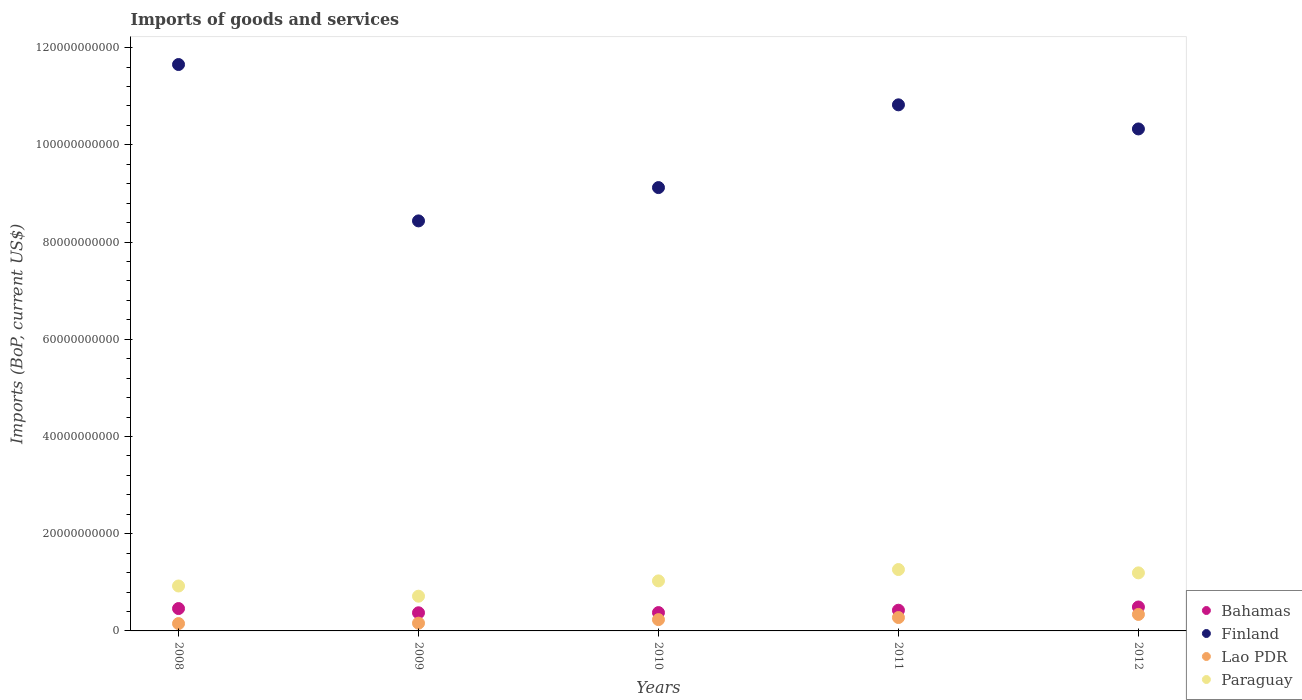How many different coloured dotlines are there?
Provide a short and direct response. 4. Is the number of dotlines equal to the number of legend labels?
Offer a very short reply. Yes. What is the amount spent on imports in Finland in 2011?
Your response must be concise. 1.08e+11. Across all years, what is the maximum amount spent on imports in Paraguay?
Your response must be concise. 1.26e+1. Across all years, what is the minimum amount spent on imports in Paraguay?
Your response must be concise. 7.14e+09. In which year was the amount spent on imports in Paraguay maximum?
Provide a short and direct response. 2011. In which year was the amount spent on imports in Bahamas minimum?
Ensure brevity in your answer.  2009. What is the total amount spent on imports in Bahamas in the graph?
Your answer should be compact. 2.13e+1. What is the difference between the amount spent on imports in Lao PDR in 2010 and that in 2012?
Your response must be concise. -1.07e+09. What is the difference between the amount spent on imports in Finland in 2010 and the amount spent on imports in Bahamas in 2012?
Your answer should be compact. 8.63e+1. What is the average amount spent on imports in Finland per year?
Keep it short and to the point. 1.01e+11. In the year 2011, what is the difference between the amount spent on imports in Bahamas and amount spent on imports in Finland?
Ensure brevity in your answer.  -1.04e+11. In how many years, is the amount spent on imports in Paraguay greater than 12000000000 US$?
Make the answer very short. 1. What is the ratio of the amount spent on imports in Lao PDR in 2008 to that in 2010?
Your answer should be compact. 0.65. Is the difference between the amount spent on imports in Bahamas in 2010 and 2012 greater than the difference between the amount spent on imports in Finland in 2010 and 2012?
Ensure brevity in your answer.  Yes. What is the difference between the highest and the second highest amount spent on imports in Bahamas?
Offer a terse response. 3.21e+08. What is the difference between the highest and the lowest amount spent on imports in Lao PDR?
Your answer should be very brief. 1.88e+09. Is the sum of the amount spent on imports in Paraguay in 2009 and 2011 greater than the maximum amount spent on imports in Bahamas across all years?
Offer a very short reply. Yes. Is it the case that in every year, the sum of the amount spent on imports in Finland and amount spent on imports in Lao PDR  is greater than the sum of amount spent on imports in Bahamas and amount spent on imports in Paraguay?
Your answer should be very brief. No. Does the amount spent on imports in Paraguay monotonically increase over the years?
Your answer should be compact. No. Is the amount spent on imports in Bahamas strictly greater than the amount spent on imports in Paraguay over the years?
Provide a short and direct response. No. What is the difference between two consecutive major ticks on the Y-axis?
Your answer should be very brief. 2.00e+1. Does the graph contain grids?
Your response must be concise. No. Where does the legend appear in the graph?
Make the answer very short. Bottom right. What is the title of the graph?
Keep it short and to the point. Imports of goods and services. Does "European Union" appear as one of the legend labels in the graph?
Provide a succinct answer. No. What is the label or title of the X-axis?
Provide a succinct answer. Years. What is the label or title of the Y-axis?
Keep it short and to the point. Imports (BoP, current US$). What is the Imports (BoP, current US$) of Bahamas in 2008?
Provide a succinct answer. 4.60e+09. What is the Imports (BoP, current US$) in Finland in 2008?
Your answer should be compact. 1.17e+11. What is the Imports (BoP, current US$) of Lao PDR in 2008?
Your answer should be compact. 1.51e+09. What is the Imports (BoP, current US$) of Paraguay in 2008?
Offer a very short reply. 9.24e+09. What is the Imports (BoP, current US$) of Bahamas in 2009?
Ensure brevity in your answer.  3.73e+09. What is the Imports (BoP, current US$) in Finland in 2009?
Keep it short and to the point. 8.43e+1. What is the Imports (BoP, current US$) in Lao PDR in 2009?
Provide a short and direct response. 1.60e+09. What is the Imports (BoP, current US$) of Paraguay in 2009?
Ensure brevity in your answer.  7.14e+09. What is the Imports (BoP, current US$) in Bahamas in 2010?
Your answer should be compact. 3.77e+09. What is the Imports (BoP, current US$) of Finland in 2010?
Give a very brief answer. 9.12e+1. What is the Imports (BoP, current US$) of Lao PDR in 2010?
Offer a very short reply. 2.32e+09. What is the Imports (BoP, current US$) in Paraguay in 2010?
Keep it short and to the point. 1.03e+1. What is the Imports (BoP, current US$) of Bahamas in 2011?
Your response must be concise. 4.26e+09. What is the Imports (BoP, current US$) in Finland in 2011?
Offer a terse response. 1.08e+11. What is the Imports (BoP, current US$) in Lao PDR in 2011?
Keep it short and to the point. 2.75e+09. What is the Imports (BoP, current US$) in Paraguay in 2011?
Your answer should be compact. 1.26e+1. What is the Imports (BoP, current US$) of Bahamas in 2012?
Provide a short and direct response. 4.92e+09. What is the Imports (BoP, current US$) in Finland in 2012?
Provide a succinct answer. 1.03e+11. What is the Imports (BoP, current US$) in Lao PDR in 2012?
Offer a very short reply. 3.39e+09. What is the Imports (BoP, current US$) in Paraguay in 2012?
Ensure brevity in your answer.  1.19e+1. Across all years, what is the maximum Imports (BoP, current US$) in Bahamas?
Provide a succinct answer. 4.92e+09. Across all years, what is the maximum Imports (BoP, current US$) of Finland?
Give a very brief answer. 1.17e+11. Across all years, what is the maximum Imports (BoP, current US$) of Lao PDR?
Give a very brief answer. 3.39e+09. Across all years, what is the maximum Imports (BoP, current US$) of Paraguay?
Provide a succinct answer. 1.26e+1. Across all years, what is the minimum Imports (BoP, current US$) in Bahamas?
Your answer should be compact. 3.73e+09. Across all years, what is the minimum Imports (BoP, current US$) in Finland?
Your answer should be very brief. 8.43e+1. Across all years, what is the minimum Imports (BoP, current US$) in Lao PDR?
Make the answer very short. 1.51e+09. Across all years, what is the minimum Imports (BoP, current US$) in Paraguay?
Your answer should be very brief. 7.14e+09. What is the total Imports (BoP, current US$) in Bahamas in the graph?
Your answer should be very brief. 2.13e+1. What is the total Imports (BoP, current US$) of Finland in the graph?
Make the answer very short. 5.04e+11. What is the total Imports (BoP, current US$) in Lao PDR in the graph?
Your answer should be compact. 1.16e+1. What is the total Imports (BoP, current US$) in Paraguay in the graph?
Provide a succinct answer. 5.12e+1. What is the difference between the Imports (BoP, current US$) in Bahamas in 2008 and that in 2009?
Your answer should be very brief. 8.70e+08. What is the difference between the Imports (BoP, current US$) in Finland in 2008 and that in 2009?
Offer a very short reply. 3.22e+1. What is the difference between the Imports (BoP, current US$) of Lao PDR in 2008 and that in 2009?
Provide a short and direct response. -8.56e+07. What is the difference between the Imports (BoP, current US$) of Paraguay in 2008 and that in 2009?
Provide a succinct answer. 2.10e+09. What is the difference between the Imports (BoP, current US$) in Bahamas in 2008 and that in 2010?
Provide a short and direct response. 8.29e+08. What is the difference between the Imports (BoP, current US$) in Finland in 2008 and that in 2010?
Offer a very short reply. 2.53e+1. What is the difference between the Imports (BoP, current US$) in Lao PDR in 2008 and that in 2010?
Keep it short and to the point. -8.12e+08. What is the difference between the Imports (BoP, current US$) of Paraguay in 2008 and that in 2010?
Provide a short and direct response. -1.05e+09. What is the difference between the Imports (BoP, current US$) in Bahamas in 2008 and that in 2011?
Your answer should be very brief. 3.44e+08. What is the difference between the Imports (BoP, current US$) in Finland in 2008 and that in 2011?
Your answer should be compact. 8.29e+09. What is the difference between the Imports (BoP, current US$) in Lao PDR in 2008 and that in 2011?
Make the answer very short. -1.24e+09. What is the difference between the Imports (BoP, current US$) of Paraguay in 2008 and that in 2011?
Provide a short and direct response. -3.38e+09. What is the difference between the Imports (BoP, current US$) of Bahamas in 2008 and that in 2012?
Provide a succinct answer. -3.21e+08. What is the difference between the Imports (BoP, current US$) in Finland in 2008 and that in 2012?
Offer a terse response. 1.32e+1. What is the difference between the Imports (BoP, current US$) of Lao PDR in 2008 and that in 2012?
Offer a terse response. -1.88e+09. What is the difference between the Imports (BoP, current US$) in Paraguay in 2008 and that in 2012?
Your answer should be very brief. -2.70e+09. What is the difference between the Imports (BoP, current US$) of Bahamas in 2009 and that in 2010?
Ensure brevity in your answer.  -4.07e+07. What is the difference between the Imports (BoP, current US$) of Finland in 2009 and that in 2010?
Provide a succinct answer. -6.85e+09. What is the difference between the Imports (BoP, current US$) of Lao PDR in 2009 and that in 2010?
Your answer should be compact. -7.27e+08. What is the difference between the Imports (BoP, current US$) of Paraguay in 2009 and that in 2010?
Offer a terse response. -3.15e+09. What is the difference between the Imports (BoP, current US$) in Bahamas in 2009 and that in 2011?
Ensure brevity in your answer.  -5.26e+08. What is the difference between the Imports (BoP, current US$) in Finland in 2009 and that in 2011?
Your response must be concise. -2.39e+1. What is the difference between the Imports (BoP, current US$) of Lao PDR in 2009 and that in 2011?
Keep it short and to the point. -1.16e+09. What is the difference between the Imports (BoP, current US$) in Paraguay in 2009 and that in 2011?
Your response must be concise. -5.48e+09. What is the difference between the Imports (BoP, current US$) in Bahamas in 2009 and that in 2012?
Your response must be concise. -1.19e+09. What is the difference between the Imports (BoP, current US$) of Finland in 2009 and that in 2012?
Ensure brevity in your answer.  -1.89e+1. What is the difference between the Imports (BoP, current US$) in Lao PDR in 2009 and that in 2012?
Keep it short and to the point. -1.80e+09. What is the difference between the Imports (BoP, current US$) in Paraguay in 2009 and that in 2012?
Make the answer very short. -4.80e+09. What is the difference between the Imports (BoP, current US$) of Bahamas in 2010 and that in 2011?
Provide a short and direct response. -4.85e+08. What is the difference between the Imports (BoP, current US$) in Finland in 2010 and that in 2011?
Provide a succinct answer. -1.70e+1. What is the difference between the Imports (BoP, current US$) in Lao PDR in 2010 and that in 2011?
Ensure brevity in your answer.  -4.30e+08. What is the difference between the Imports (BoP, current US$) in Paraguay in 2010 and that in 2011?
Make the answer very short. -2.33e+09. What is the difference between the Imports (BoP, current US$) of Bahamas in 2010 and that in 2012?
Provide a short and direct response. -1.15e+09. What is the difference between the Imports (BoP, current US$) of Finland in 2010 and that in 2012?
Make the answer very short. -1.21e+1. What is the difference between the Imports (BoP, current US$) of Lao PDR in 2010 and that in 2012?
Give a very brief answer. -1.07e+09. What is the difference between the Imports (BoP, current US$) of Paraguay in 2010 and that in 2012?
Offer a terse response. -1.65e+09. What is the difference between the Imports (BoP, current US$) of Bahamas in 2011 and that in 2012?
Provide a short and direct response. -6.65e+08. What is the difference between the Imports (BoP, current US$) in Finland in 2011 and that in 2012?
Offer a very short reply. 4.96e+09. What is the difference between the Imports (BoP, current US$) of Lao PDR in 2011 and that in 2012?
Your answer should be compact. -6.41e+08. What is the difference between the Imports (BoP, current US$) of Paraguay in 2011 and that in 2012?
Give a very brief answer. 6.85e+08. What is the difference between the Imports (BoP, current US$) of Bahamas in 2008 and the Imports (BoP, current US$) of Finland in 2009?
Give a very brief answer. -7.97e+1. What is the difference between the Imports (BoP, current US$) of Bahamas in 2008 and the Imports (BoP, current US$) of Lao PDR in 2009?
Offer a very short reply. 3.01e+09. What is the difference between the Imports (BoP, current US$) in Bahamas in 2008 and the Imports (BoP, current US$) in Paraguay in 2009?
Offer a very short reply. -2.54e+09. What is the difference between the Imports (BoP, current US$) in Finland in 2008 and the Imports (BoP, current US$) in Lao PDR in 2009?
Ensure brevity in your answer.  1.15e+11. What is the difference between the Imports (BoP, current US$) of Finland in 2008 and the Imports (BoP, current US$) of Paraguay in 2009?
Your response must be concise. 1.09e+11. What is the difference between the Imports (BoP, current US$) in Lao PDR in 2008 and the Imports (BoP, current US$) in Paraguay in 2009?
Your answer should be compact. -5.63e+09. What is the difference between the Imports (BoP, current US$) of Bahamas in 2008 and the Imports (BoP, current US$) of Finland in 2010?
Keep it short and to the point. -8.66e+1. What is the difference between the Imports (BoP, current US$) of Bahamas in 2008 and the Imports (BoP, current US$) of Lao PDR in 2010?
Keep it short and to the point. 2.28e+09. What is the difference between the Imports (BoP, current US$) in Bahamas in 2008 and the Imports (BoP, current US$) in Paraguay in 2010?
Your answer should be compact. -5.69e+09. What is the difference between the Imports (BoP, current US$) of Finland in 2008 and the Imports (BoP, current US$) of Lao PDR in 2010?
Your answer should be very brief. 1.14e+11. What is the difference between the Imports (BoP, current US$) of Finland in 2008 and the Imports (BoP, current US$) of Paraguay in 2010?
Offer a very short reply. 1.06e+11. What is the difference between the Imports (BoP, current US$) in Lao PDR in 2008 and the Imports (BoP, current US$) in Paraguay in 2010?
Give a very brief answer. -8.78e+09. What is the difference between the Imports (BoP, current US$) of Bahamas in 2008 and the Imports (BoP, current US$) of Finland in 2011?
Give a very brief answer. -1.04e+11. What is the difference between the Imports (BoP, current US$) in Bahamas in 2008 and the Imports (BoP, current US$) in Lao PDR in 2011?
Your response must be concise. 1.85e+09. What is the difference between the Imports (BoP, current US$) in Bahamas in 2008 and the Imports (BoP, current US$) in Paraguay in 2011?
Keep it short and to the point. -8.02e+09. What is the difference between the Imports (BoP, current US$) in Finland in 2008 and the Imports (BoP, current US$) in Lao PDR in 2011?
Your answer should be compact. 1.14e+11. What is the difference between the Imports (BoP, current US$) of Finland in 2008 and the Imports (BoP, current US$) of Paraguay in 2011?
Offer a terse response. 1.04e+11. What is the difference between the Imports (BoP, current US$) of Lao PDR in 2008 and the Imports (BoP, current US$) of Paraguay in 2011?
Give a very brief answer. -1.11e+1. What is the difference between the Imports (BoP, current US$) of Bahamas in 2008 and the Imports (BoP, current US$) of Finland in 2012?
Make the answer very short. -9.87e+1. What is the difference between the Imports (BoP, current US$) of Bahamas in 2008 and the Imports (BoP, current US$) of Lao PDR in 2012?
Your answer should be very brief. 1.21e+09. What is the difference between the Imports (BoP, current US$) in Bahamas in 2008 and the Imports (BoP, current US$) in Paraguay in 2012?
Give a very brief answer. -7.34e+09. What is the difference between the Imports (BoP, current US$) in Finland in 2008 and the Imports (BoP, current US$) in Lao PDR in 2012?
Give a very brief answer. 1.13e+11. What is the difference between the Imports (BoP, current US$) of Finland in 2008 and the Imports (BoP, current US$) of Paraguay in 2012?
Offer a very short reply. 1.05e+11. What is the difference between the Imports (BoP, current US$) in Lao PDR in 2008 and the Imports (BoP, current US$) in Paraguay in 2012?
Your response must be concise. -1.04e+1. What is the difference between the Imports (BoP, current US$) of Bahamas in 2009 and the Imports (BoP, current US$) of Finland in 2010?
Give a very brief answer. -8.75e+1. What is the difference between the Imports (BoP, current US$) in Bahamas in 2009 and the Imports (BoP, current US$) in Lao PDR in 2010?
Offer a terse response. 1.41e+09. What is the difference between the Imports (BoP, current US$) of Bahamas in 2009 and the Imports (BoP, current US$) of Paraguay in 2010?
Offer a very short reply. -6.56e+09. What is the difference between the Imports (BoP, current US$) in Finland in 2009 and the Imports (BoP, current US$) in Lao PDR in 2010?
Ensure brevity in your answer.  8.20e+1. What is the difference between the Imports (BoP, current US$) in Finland in 2009 and the Imports (BoP, current US$) in Paraguay in 2010?
Your answer should be compact. 7.41e+1. What is the difference between the Imports (BoP, current US$) in Lao PDR in 2009 and the Imports (BoP, current US$) in Paraguay in 2010?
Provide a short and direct response. -8.70e+09. What is the difference between the Imports (BoP, current US$) of Bahamas in 2009 and the Imports (BoP, current US$) of Finland in 2011?
Your answer should be very brief. -1.04e+11. What is the difference between the Imports (BoP, current US$) in Bahamas in 2009 and the Imports (BoP, current US$) in Lao PDR in 2011?
Make the answer very short. 9.78e+08. What is the difference between the Imports (BoP, current US$) of Bahamas in 2009 and the Imports (BoP, current US$) of Paraguay in 2011?
Make the answer very short. -8.89e+09. What is the difference between the Imports (BoP, current US$) in Finland in 2009 and the Imports (BoP, current US$) in Lao PDR in 2011?
Your response must be concise. 8.16e+1. What is the difference between the Imports (BoP, current US$) in Finland in 2009 and the Imports (BoP, current US$) in Paraguay in 2011?
Keep it short and to the point. 7.17e+1. What is the difference between the Imports (BoP, current US$) of Lao PDR in 2009 and the Imports (BoP, current US$) of Paraguay in 2011?
Offer a terse response. -1.10e+1. What is the difference between the Imports (BoP, current US$) of Bahamas in 2009 and the Imports (BoP, current US$) of Finland in 2012?
Ensure brevity in your answer.  -9.95e+1. What is the difference between the Imports (BoP, current US$) of Bahamas in 2009 and the Imports (BoP, current US$) of Lao PDR in 2012?
Offer a terse response. 3.38e+08. What is the difference between the Imports (BoP, current US$) of Bahamas in 2009 and the Imports (BoP, current US$) of Paraguay in 2012?
Your answer should be very brief. -8.21e+09. What is the difference between the Imports (BoP, current US$) of Finland in 2009 and the Imports (BoP, current US$) of Lao PDR in 2012?
Your answer should be very brief. 8.09e+1. What is the difference between the Imports (BoP, current US$) in Finland in 2009 and the Imports (BoP, current US$) in Paraguay in 2012?
Make the answer very short. 7.24e+1. What is the difference between the Imports (BoP, current US$) in Lao PDR in 2009 and the Imports (BoP, current US$) in Paraguay in 2012?
Ensure brevity in your answer.  -1.03e+1. What is the difference between the Imports (BoP, current US$) in Bahamas in 2010 and the Imports (BoP, current US$) in Finland in 2011?
Provide a short and direct response. -1.04e+11. What is the difference between the Imports (BoP, current US$) of Bahamas in 2010 and the Imports (BoP, current US$) of Lao PDR in 2011?
Your answer should be very brief. 1.02e+09. What is the difference between the Imports (BoP, current US$) in Bahamas in 2010 and the Imports (BoP, current US$) in Paraguay in 2011?
Your answer should be compact. -8.85e+09. What is the difference between the Imports (BoP, current US$) of Finland in 2010 and the Imports (BoP, current US$) of Lao PDR in 2011?
Make the answer very short. 8.84e+1. What is the difference between the Imports (BoP, current US$) in Finland in 2010 and the Imports (BoP, current US$) in Paraguay in 2011?
Your answer should be compact. 7.86e+1. What is the difference between the Imports (BoP, current US$) in Lao PDR in 2010 and the Imports (BoP, current US$) in Paraguay in 2011?
Provide a succinct answer. -1.03e+1. What is the difference between the Imports (BoP, current US$) of Bahamas in 2010 and the Imports (BoP, current US$) of Finland in 2012?
Offer a very short reply. -9.95e+1. What is the difference between the Imports (BoP, current US$) of Bahamas in 2010 and the Imports (BoP, current US$) of Lao PDR in 2012?
Ensure brevity in your answer.  3.78e+08. What is the difference between the Imports (BoP, current US$) of Bahamas in 2010 and the Imports (BoP, current US$) of Paraguay in 2012?
Provide a short and direct response. -8.17e+09. What is the difference between the Imports (BoP, current US$) of Finland in 2010 and the Imports (BoP, current US$) of Lao PDR in 2012?
Your answer should be very brief. 8.78e+1. What is the difference between the Imports (BoP, current US$) in Finland in 2010 and the Imports (BoP, current US$) in Paraguay in 2012?
Offer a very short reply. 7.93e+1. What is the difference between the Imports (BoP, current US$) of Lao PDR in 2010 and the Imports (BoP, current US$) of Paraguay in 2012?
Ensure brevity in your answer.  -9.62e+09. What is the difference between the Imports (BoP, current US$) in Bahamas in 2011 and the Imports (BoP, current US$) in Finland in 2012?
Make the answer very short. -9.90e+1. What is the difference between the Imports (BoP, current US$) in Bahamas in 2011 and the Imports (BoP, current US$) in Lao PDR in 2012?
Ensure brevity in your answer.  8.64e+08. What is the difference between the Imports (BoP, current US$) in Bahamas in 2011 and the Imports (BoP, current US$) in Paraguay in 2012?
Keep it short and to the point. -7.68e+09. What is the difference between the Imports (BoP, current US$) in Finland in 2011 and the Imports (BoP, current US$) in Lao PDR in 2012?
Your response must be concise. 1.05e+11. What is the difference between the Imports (BoP, current US$) in Finland in 2011 and the Imports (BoP, current US$) in Paraguay in 2012?
Provide a succinct answer. 9.63e+1. What is the difference between the Imports (BoP, current US$) in Lao PDR in 2011 and the Imports (BoP, current US$) in Paraguay in 2012?
Your answer should be very brief. -9.19e+09. What is the average Imports (BoP, current US$) of Bahamas per year?
Ensure brevity in your answer.  4.26e+09. What is the average Imports (BoP, current US$) in Finland per year?
Your answer should be compact. 1.01e+11. What is the average Imports (BoP, current US$) of Lao PDR per year?
Offer a terse response. 2.32e+09. What is the average Imports (BoP, current US$) of Paraguay per year?
Your response must be concise. 1.02e+1. In the year 2008, what is the difference between the Imports (BoP, current US$) in Bahamas and Imports (BoP, current US$) in Finland?
Your answer should be compact. -1.12e+11. In the year 2008, what is the difference between the Imports (BoP, current US$) of Bahamas and Imports (BoP, current US$) of Lao PDR?
Provide a succinct answer. 3.09e+09. In the year 2008, what is the difference between the Imports (BoP, current US$) of Bahamas and Imports (BoP, current US$) of Paraguay?
Keep it short and to the point. -4.64e+09. In the year 2008, what is the difference between the Imports (BoP, current US$) in Finland and Imports (BoP, current US$) in Lao PDR?
Give a very brief answer. 1.15e+11. In the year 2008, what is the difference between the Imports (BoP, current US$) of Finland and Imports (BoP, current US$) of Paraguay?
Offer a very short reply. 1.07e+11. In the year 2008, what is the difference between the Imports (BoP, current US$) of Lao PDR and Imports (BoP, current US$) of Paraguay?
Your answer should be very brief. -7.73e+09. In the year 2009, what is the difference between the Imports (BoP, current US$) in Bahamas and Imports (BoP, current US$) in Finland?
Give a very brief answer. -8.06e+1. In the year 2009, what is the difference between the Imports (BoP, current US$) of Bahamas and Imports (BoP, current US$) of Lao PDR?
Offer a terse response. 2.14e+09. In the year 2009, what is the difference between the Imports (BoP, current US$) in Bahamas and Imports (BoP, current US$) in Paraguay?
Give a very brief answer. -3.41e+09. In the year 2009, what is the difference between the Imports (BoP, current US$) of Finland and Imports (BoP, current US$) of Lao PDR?
Your answer should be compact. 8.27e+1. In the year 2009, what is the difference between the Imports (BoP, current US$) of Finland and Imports (BoP, current US$) of Paraguay?
Your response must be concise. 7.72e+1. In the year 2009, what is the difference between the Imports (BoP, current US$) of Lao PDR and Imports (BoP, current US$) of Paraguay?
Offer a terse response. -5.55e+09. In the year 2010, what is the difference between the Imports (BoP, current US$) in Bahamas and Imports (BoP, current US$) in Finland?
Offer a very short reply. -8.74e+1. In the year 2010, what is the difference between the Imports (BoP, current US$) in Bahamas and Imports (BoP, current US$) in Lao PDR?
Keep it short and to the point. 1.45e+09. In the year 2010, what is the difference between the Imports (BoP, current US$) of Bahamas and Imports (BoP, current US$) of Paraguay?
Ensure brevity in your answer.  -6.52e+09. In the year 2010, what is the difference between the Imports (BoP, current US$) in Finland and Imports (BoP, current US$) in Lao PDR?
Offer a very short reply. 8.89e+1. In the year 2010, what is the difference between the Imports (BoP, current US$) of Finland and Imports (BoP, current US$) of Paraguay?
Your answer should be very brief. 8.09e+1. In the year 2010, what is the difference between the Imports (BoP, current US$) of Lao PDR and Imports (BoP, current US$) of Paraguay?
Give a very brief answer. -7.97e+09. In the year 2011, what is the difference between the Imports (BoP, current US$) in Bahamas and Imports (BoP, current US$) in Finland?
Your answer should be very brief. -1.04e+11. In the year 2011, what is the difference between the Imports (BoP, current US$) in Bahamas and Imports (BoP, current US$) in Lao PDR?
Offer a terse response. 1.50e+09. In the year 2011, what is the difference between the Imports (BoP, current US$) in Bahamas and Imports (BoP, current US$) in Paraguay?
Your answer should be very brief. -8.37e+09. In the year 2011, what is the difference between the Imports (BoP, current US$) of Finland and Imports (BoP, current US$) of Lao PDR?
Provide a succinct answer. 1.05e+11. In the year 2011, what is the difference between the Imports (BoP, current US$) in Finland and Imports (BoP, current US$) in Paraguay?
Offer a very short reply. 9.56e+1. In the year 2011, what is the difference between the Imports (BoP, current US$) in Lao PDR and Imports (BoP, current US$) in Paraguay?
Your response must be concise. -9.87e+09. In the year 2012, what is the difference between the Imports (BoP, current US$) of Bahamas and Imports (BoP, current US$) of Finland?
Keep it short and to the point. -9.83e+1. In the year 2012, what is the difference between the Imports (BoP, current US$) of Bahamas and Imports (BoP, current US$) of Lao PDR?
Offer a very short reply. 1.53e+09. In the year 2012, what is the difference between the Imports (BoP, current US$) of Bahamas and Imports (BoP, current US$) of Paraguay?
Keep it short and to the point. -7.02e+09. In the year 2012, what is the difference between the Imports (BoP, current US$) of Finland and Imports (BoP, current US$) of Lao PDR?
Your answer should be compact. 9.99e+1. In the year 2012, what is the difference between the Imports (BoP, current US$) in Finland and Imports (BoP, current US$) in Paraguay?
Keep it short and to the point. 9.13e+1. In the year 2012, what is the difference between the Imports (BoP, current US$) of Lao PDR and Imports (BoP, current US$) of Paraguay?
Offer a terse response. -8.55e+09. What is the ratio of the Imports (BoP, current US$) of Bahamas in 2008 to that in 2009?
Provide a short and direct response. 1.23. What is the ratio of the Imports (BoP, current US$) of Finland in 2008 to that in 2009?
Your response must be concise. 1.38. What is the ratio of the Imports (BoP, current US$) of Lao PDR in 2008 to that in 2009?
Your answer should be compact. 0.95. What is the ratio of the Imports (BoP, current US$) of Paraguay in 2008 to that in 2009?
Make the answer very short. 1.29. What is the ratio of the Imports (BoP, current US$) in Bahamas in 2008 to that in 2010?
Your response must be concise. 1.22. What is the ratio of the Imports (BoP, current US$) of Finland in 2008 to that in 2010?
Your answer should be compact. 1.28. What is the ratio of the Imports (BoP, current US$) of Lao PDR in 2008 to that in 2010?
Provide a succinct answer. 0.65. What is the ratio of the Imports (BoP, current US$) in Paraguay in 2008 to that in 2010?
Offer a terse response. 0.9. What is the ratio of the Imports (BoP, current US$) in Bahamas in 2008 to that in 2011?
Ensure brevity in your answer.  1.08. What is the ratio of the Imports (BoP, current US$) in Finland in 2008 to that in 2011?
Provide a short and direct response. 1.08. What is the ratio of the Imports (BoP, current US$) in Lao PDR in 2008 to that in 2011?
Provide a short and direct response. 0.55. What is the ratio of the Imports (BoP, current US$) of Paraguay in 2008 to that in 2011?
Offer a terse response. 0.73. What is the ratio of the Imports (BoP, current US$) in Bahamas in 2008 to that in 2012?
Your answer should be very brief. 0.93. What is the ratio of the Imports (BoP, current US$) in Finland in 2008 to that in 2012?
Provide a short and direct response. 1.13. What is the ratio of the Imports (BoP, current US$) of Lao PDR in 2008 to that in 2012?
Offer a terse response. 0.45. What is the ratio of the Imports (BoP, current US$) of Paraguay in 2008 to that in 2012?
Your answer should be compact. 0.77. What is the ratio of the Imports (BoP, current US$) in Finland in 2009 to that in 2010?
Provide a short and direct response. 0.92. What is the ratio of the Imports (BoP, current US$) in Lao PDR in 2009 to that in 2010?
Your answer should be compact. 0.69. What is the ratio of the Imports (BoP, current US$) of Paraguay in 2009 to that in 2010?
Your response must be concise. 0.69. What is the ratio of the Imports (BoP, current US$) in Bahamas in 2009 to that in 2011?
Keep it short and to the point. 0.88. What is the ratio of the Imports (BoP, current US$) in Finland in 2009 to that in 2011?
Offer a very short reply. 0.78. What is the ratio of the Imports (BoP, current US$) in Lao PDR in 2009 to that in 2011?
Keep it short and to the point. 0.58. What is the ratio of the Imports (BoP, current US$) in Paraguay in 2009 to that in 2011?
Keep it short and to the point. 0.57. What is the ratio of the Imports (BoP, current US$) in Bahamas in 2009 to that in 2012?
Make the answer very short. 0.76. What is the ratio of the Imports (BoP, current US$) in Finland in 2009 to that in 2012?
Offer a very short reply. 0.82. What is the ratio of the Imports (BoP, current US$) of Lao PDR in 2009 to that in 2012?
Keep it short and to the point. 0.47. What is the ratio of the Imports (BoP, current US$) of Paraguay in 2009 to that in 2012?
Keep it short and to the point. 0.6. What is the ratio of the Imports (BoP, current US$) of Bahamas in 2010 to that in 2011?
Ensure brevity in your answer.  0.89. What is the ratio of the Imports (BoP, current US$) in Finland in 2010 to that in 2011?
Your answer should be compact. 0.84. What is the ratio of the Imports (BoP, current US$) of Lao PDR in 2010 to that in 2011?
Make the answer very short. 0.84. What is the ratio of the Imports (BoP, current US$) in Paraguay in 2010 to that in 2011?
Offer a very short reply. 0.82. What is the ratio of the Imports (BoP, current US$) in Bahamas in 2010 to that in 2012?
Offer a very short reply. 0.77. What is the ratio of the Imports (BoP, current US$) in Finland in 2010 to that in 2012?
Offer a terse response. 0.88. What is the ratio of the Imports (BoP, current US$) in Lao PDR in 2010 to that in 2012?
Offer a terse response. 0.68. What is the ratio of the Imports (BoP, current US$) of Paraguay in 2010 to that in 2012?
Your answer should be compact. 0.86. What is the ratio of the Imports (BoP, current US$) in Bahamas in 2011 to that in 2012?
Your response must be concise. 0.86. What is the ratio of the Imports (BoP, current US$) in Finland in 2011 to that in 2012?
Provide a short and direct response. 1.05. What is the ratio of the Imports (BoP, current US$) in Lao PDR in 2011 to that in 2012?
Provide a succinct answer. 0.81. What is the ratio of the Imports (BoP, current US$) in Paraguay in 2011 to that in 2012?
Keep it short and to the point. 1.06. What is the difference between the highest and the second highest Imports (BoP, current US$) of Bahamas?
Offer a very short reply. 3.21e+08. What is the difference between the highest and the second highest Imports (BoP, current US$) in Finland?
Give a very brief answer. 8.29e+09. What is the difference between the highest and the second highest Imports (BoP, current US$) in Lao PDR?
Provide a short and direct response. 6.41e+08. What is the difference between the highest and the second highest Imports (BoP, current US$) of Paraguay?
Ensure brevity in your answer.  6.85e+08. What is the difference between the highest and the lowest Imports (BoP, current US$) of Bahamas?
Ensure brevity in your answer.  1.19e+09. What is the difference between the highest and the lowest Imports (BoP, current US$) of Finland?
Your answer should be very brief. 3.22e+1. What is the difference between the highest and the lowest Imports (BoP, current US$) in Lao PDR?
Make the answer very short. 1.88e+09. What is the difference between the highest and the lowest Imports (BoP, current US$) in Paraguay?
Your response must be concise. 5.48e+09. 